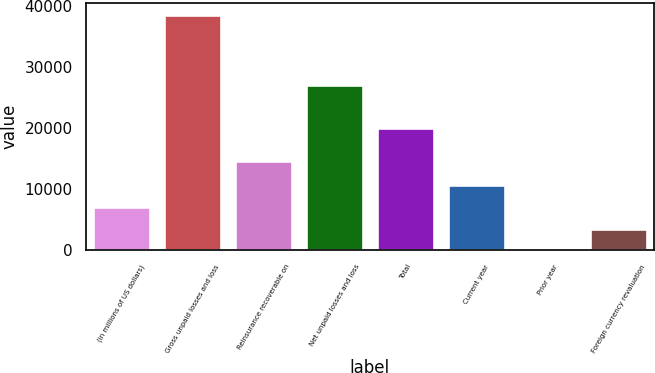<chart> <loc_0><loc_0><loc_500><loc_500><bar_chart><fcel>(in millions of US dollars)<fcel>Gross unpaid losses and loss<fcel>Reinsurance recoverable on<fcel>Net unpaid losses and loss<fcel>Total<fcel>Current year<fcel>Prior year<fcel>Foreign currency revaluation<nl><fcel>7113<fcel>38605.5<fcel>14597<fcel>27087<fcel>19986<fcel>10663.5<fcel>12<fcel>3562.5<nl></chart> 